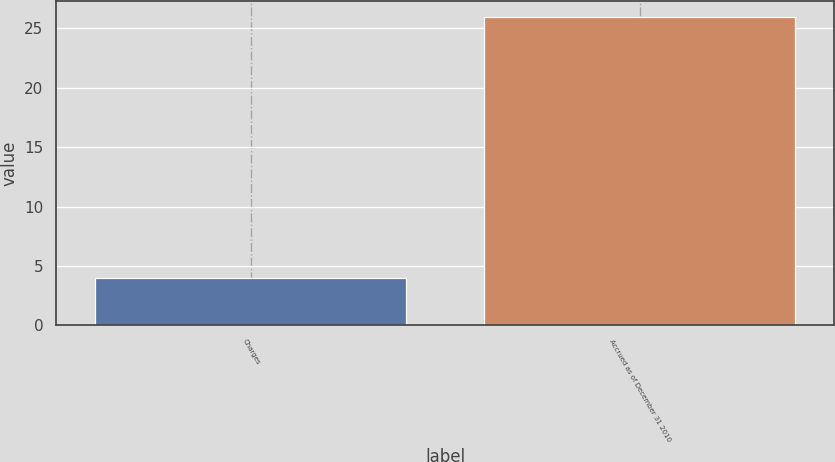<chart> <loc_0><loc_0><loc_500><loc_500><bar_chart><fcel>Charges<fcel>Accrued as of December 31 2010<nl><fcel>4<fcel>26<nl></chart> 